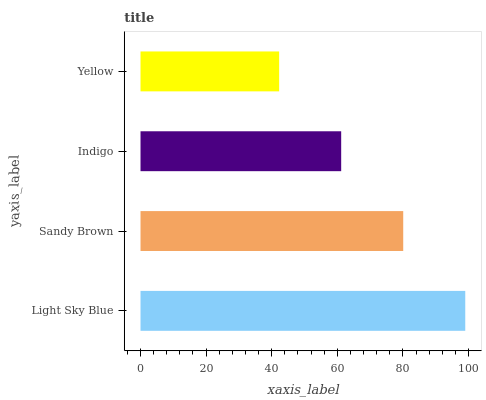Is Yellow the minimum?
Answer yes or no. Yes. Is Light Sky Blue the maximum?
Answer yes or no. Yes. Is Sandy Brown the minimum?
Answer yes or no. No. Is Sandy Brown the maximum?
Answer yes or no. No. Is Light Sky Blue greater than Sandy Brown?
Answer yes or no. Yes. Is Sandy Brown less than Light Sky Blue?
Answer yes or no. Yes. Is Sandy Brown greater than Light Sky Blue?
Answer yes or no. No. Is Light Sky Blue less than Sandy Brown?
Answer yes or no. No. Is Sandy Brown the high median?
Answer yes or no. Yes. Is Indigo the low median?
Answer yes or no. Yes. Is Light Sky Blue the high median?
Answer yes or no. No. Is Sandy Brown the low median?
Answer yes or no. No. 